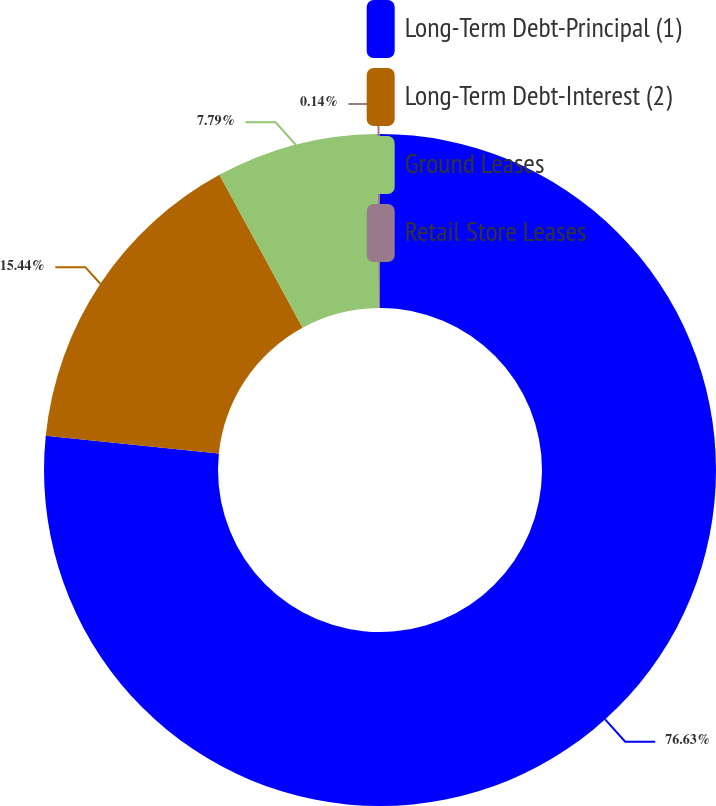Convert chart to OTSL. <chart><loc_0><loc_0><loc_500><loc_500><pie_chart><fcel>Long-Term Debt-Principal (1)<fcel>Long-Term Debt-Interest (2)<fcel>Ground Leases<fcel>Retail Store Leases<nl><fcel>76.63%<fcel>15.44%<fcel>7.79%<fcel>0.14%<nl></chart> 